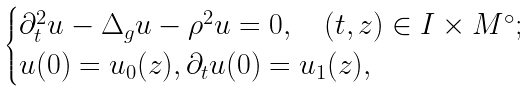Convert formula to latex. <formula><loc_0><loc_0><loc_500><loc_500>\begin{cases} \partial _ { t } ^ { 2 } u - \Delta _ { g } u - \rho ^ { 2 } u = 0 , \quad ( t , z ) \in I \times M ^ { \circ } ; \\ u ( 0 ) = u _ { 0 } ( z ) , \partial _ { t } u ( 0 ) = u _ { 1 } ( z ) , \end{cases}</formula> 